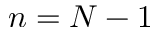Convert formula to latex. <formula><loc_0><loc_0><loc_500><loc_500>n = N - 1</formula> 